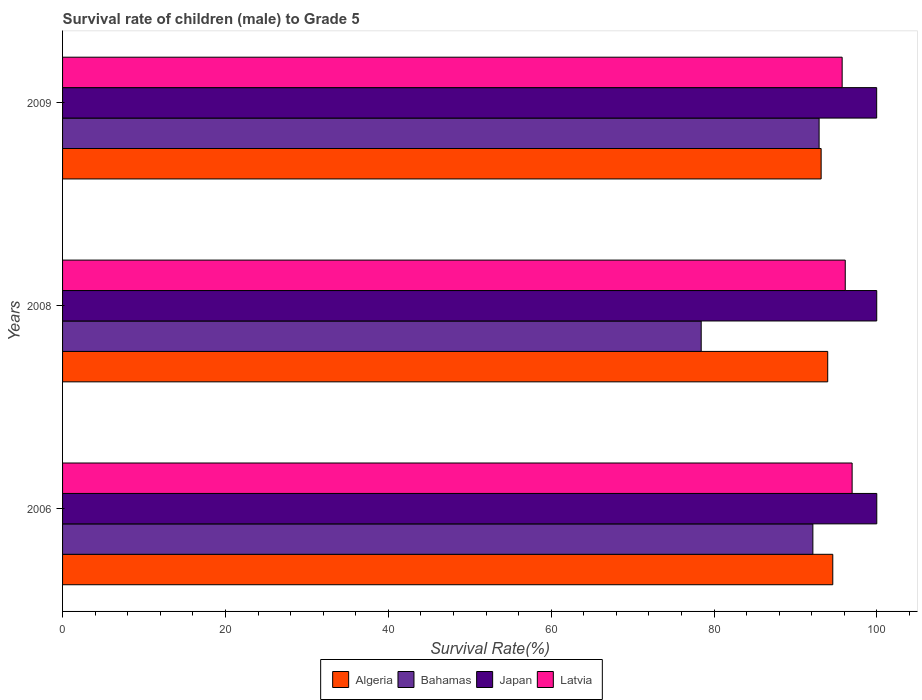How many different coloured bars are there?
Offer a terse response. 4. Are the number of bars on each tick of the Y-axis equal?
Your response must be concise. Yes. How many bars are there on the 3rd tick from the top?
Your answer should be compact. 4. How many bars are there on the 1st tick from the bottom?
Make the answer very short. 4. In how many cases, is the number of bars for a given year not equal to the number of legend labels?
Your response must be concise. 0. What is the survival rate of male children to grade 5 in Bahamas in 2009?
Ensure brevity in your answer.  92.91. Across all years, what is the maximum survival rate of male children to grade 5 in Latvia?
Provide a succinct answer. 96.96. Across all years, what is the minimum survival rate of male children to grade 5 in Japan?
Offer a terse response. 99.97. In which year was the survival rate of male children to grade 5 in Japan minimum?
Provide a succinct answer. 2009. What is the total survival rate of male children to grade 5 in Latvia in the graph?
Offer a very short reply. 288.81. What is the difference between the survival rate of male children to grade 5 in Bahamas in 2006 and that in 2009?
Make the answer very short. -0.77. What is the difference between the survival rate of male children to grade 5 in Bahamas in 2006 and the survival rate of male children to grade 5 in Latvia in 2009?
Your response must be concise. -3.6. What is the average survival rate of male children to grade 5 in Algeria per year?
Keep it short and to the point. 93.9. In the year 2008, what is the difference between the survival rate of male children to grade 5 in Algeria and survival rate of male children to grade 5 in Japan?
Provide a short and direct response. -6.02. In how many years, is the survival rate of male children to grade 5 in Latvia greater than 4 %?
Make the answer very short. 3. What is the ratio of the survival rate of male children to grade 5 in Bahamas in 2006 to that in 2008?
Make the answer very short. 1.17. Is the survival rate of male children to grade 5 in Latvia in 2006 less than that in 2008?
Keep it short and to the point. No. What is the difference between the highest and the second highest survival rate of male children to grade 5 in Japan?
Offer a very short reply. 0. What is the difference between the highest and the lowest survival rate of male children to grade 5 in Bahamas?
Give a very brief answer. 14.48. Is the sum of the survival rate of male children to grade 5 in Latvia in 2006 and 2008 greater than the maximum survival rate of male children to grade 5 in Japan across all years?
Offer a terse response. Yes. What does the 3rd bar from the top in 2008 represents?
Offer a very short reply. Bahamas. What does the 4th bar from the bottom in 2006 represents?
Offer a very short reply. Latvia. How many bars are there?
Make the answer very short. 12. Are all the bars in the graph horizontal?
Your answer should be very brief. Yes. How many years are there in the graph?
Offer a very short reply. 3. What is the difference between two consecutive major ticks on the X-axis?
Your answer should be compact. 20. How are the legend labels stacked?
Keep it short and to the point. Horizontal. What is the title of the graph?
Ensure brevity in your answer.  Survival rate of children (male) to Grade 5. What is the label or title of the X-axis?
Offer a very short reply. Survival Rate(%). What is the Survival Rate(%) of Algeria in 2006?
Ensure brevity in your answer.  94.58. What is the Survival Rate(%) in Bahamas in 2006?
Offer a terse response. 92.14. What is the Survival Rate(%) in Japan in 2006?
Your response must be concise. 99.99. What is the Survival Rate(%) in Latvia in 2006?
Provide a succinct answer. 96.96. What is the Survival Rate(%) of Algeria in 2008?
Your response must be concise. 93.96. What is the Survival Rate(%) in Bahamas in 2008?
Give a very brief answer. 78.43. What is the Survival Rate(%) in Japan in 2008?
Ensure brevity in your answer.  99.98. What is the Survival Rate(%) of Latvia in 2008?
Your answer should be compact. 96.12. What is the Survival Rate(%) in Algeria in 2009?
Provide a short and direct response. 93.16. What is the Survival Rate(%) of Bahamas in 2009?
Your response must be concise. 92.91. What is the Survival Rate(%) in Japan in 2009?
Provide a short and direct response. 99.97. What is the Survival Rate(%) of Latvia in 2009?
Provide a short and direct response. 95.74. Across all years, what is the maximum Survival Rate(%) of Algeria?
Provide a succinct answer. 94.58. Across all years, what is the maximum Survival Rate(%) of Bahamas?
Your answer should be very brief. 92.91. Across all years, what is the maximum Survival Rate(%) of Japan?
Ensure brevity in your answer.  99.99. Across all years, what is the maximum Survival Rate(%) in Latvia?
Keep it short and to the point. 96.96. Across all years, what is the minimum Survival Rate(%) of Algeria?
Provide a short and direct response. 93.16. Across all years, what is the minimum Survival Rate(%) of Bahamas?
Give a very brief answer. 78.43. Across all years, what is the minimum Survival Rate(%) of Japan?
Ensure brevity in your answer.  99.97. Across all years, what is the minimum Survival Rate(%) in Latvia?
Ensure brevity in your answer.  95.74. What is the total Survival Rate(%) in Algeria in the graph?
Provide a succinct answer. 281.7. What is the total Survival Rate(%) in Bahamas in the graph?
Offer a very short reply. 263.47. What is the total Survival Rate(%) of Japan in the graph?
Your answer should be very brief. 299.95. What is the total Survival Rate(%) of Latvia in the graph?
Offer a very short reply. 288.81. What is the difference between the Survival Rate(%) of Algeria in 2006 and that in 2008?
Provide a succinct answer. 0.62. What is the difference between the Survival Rate(%) in Bahamas in 2006 and that in 2008?
Make the answer very short. 13.71. What is the difference between the Survival Rate(%) in Japan in 2006 and that in 2008?
Your answer should be compact. 0. What is the difference between the Survival Rate(%) in Latvia in 2006 and that in 2008?
Your answer should be compact. 0.84. What is the difference between the Survival Rate(%) of Algeria in 2006 and that in 2009?
Offer a terse response. 1.43. What is the difference between the Survival Rate(%) in Bahamas in 2006 and that in 2009?
Your response must be concise. -0.77. What is the difference between the Survival Rate(%) in Japan in 2006 and that in 2009?
Offer a very short reply. 0.01. What is the difference between the Survival Rate(%) in Latvia in 2006 and that in 2009?
Your answer should be compact. 1.22. What is the difference between the Survival Rate(%) of Algeria in 2008 and that in 2009?
Provide a succinct answer. 0.81. What is the difference between the Survival Rate(%) in Bahamas in 2008 and that in 2009?
Your response must be concise. -14.48. What is the difference between the Survival Rate(%) of Japan in 2008 and that in 2009?
Provide a short and direct response. 0.01. What is the difference between the Survival Rate(%) of Latvia in 2008 and that in 2009?
Give a very brief answer. 0.38. What is the difference between the Survival Rate(%) of Algeria in 2006 and the Survival Rate(%) of Bahamas in 2008?
Offer a very short reply. 16.16. What is the difference between the Survival Rate(%) of Algeria in 2006 and the Survival Rate(%) of Japan in 2008?
Your answer should be compact. -5.4. What is the difference between the Survival Rate(%) in Algeria in 2006 and the Survival Rate(%) in Latvia in 2008?
Give a very brief answer. -1.53. What is the difference between the Survival Rate(%) of Bahamas in 2006 and the Survival Rate(%) of Japan in 2008?
Make the answer very short. -7.84. What is the difference between the Survival Rate(%) of Bahamas in 2006 and the Survival Rate(%) of Latvia in 2008?
Your answer should be very brief. -3.98. What is the difference between the Survival Rate(%) of Japan in 2006 and the Survival Rate(%) of Latvia in 2008?
Keep it short and to the point. 3.87. What is the difference between the Survival Rate(%) in Algeria in 2006 and the Survival Rate(%) in Bahamas in 2009?
Your response must be concise. 1.68. What is the difference between the Survival Rate(%) in Algeria in 2006 and the Survival Rate(%) in Japan in 2009?
Make the answer very short. -5.39. What is the difference between the Survival Rate(%) in Algeria in 2006 and the Survival Rate(%) in Latvia in 2009?
Your answer should be compact. -1.15. What is the difference between the Survival Rate(%) of Bahamas in 2006 and the Survival Rate(%) of Japan in 2009?
Offer a terse response. -7.83. What is the difference between the Survival Rate(%) of Bahamas in 2006 and the Survival Rate(%) of Latvia in 2009?
Make the answer very short. -3.6. What is the difference between the Survival Rate(%) of Japan in 2006 and the Survival Rate(%) of Latvia in 2009?
Make the answer very short. 4.25. What is the difference between the Survival Rate(%) of Algeria in 2008 and the Survival Rate(%) of Bahamas in 2009?
Your answer should be compact. 1.06. What is the difference between the Survival Rate(%) in Algeria in 2008 and the Survival Rate(%) in Japan in 2009?
Keep it short and to the point. -6.01. What is the difference between the Survival Rate(%) of Algeria in 2008 and the Survival Rate(%) of Latvia in 2009?
Keep it short and to the point. -1.77. What is the difference between the Survival Rate(%) of Bahamas in 2008 and the Survival Rate(%) of Japan in 2009?
Make the answer very short. -21.55. What is the difference between the Survival Rate(%) in Bahamas in 2008 and the Survival Rate(%) in Latvia in 2009?
Your response must be concise. -17.31. What is the difference between the Survival Rate(%) of Japan in 2008 and the Survival Rate(%) of Latvia in 2009?
Provide a short and direct response. 4.25. What is the average Survival Rate(%) of Algeria per year?
Provide a short and direct response. 93.9. What is the average Survival Rate(%) of Bahamas per year?
Your answer should be very brief. 87.82. What is the average Survival Rate(%) of Japan per year?
Provide a short and direct response. 99.98. What is the average Survival Rate(%) of Latvia per year?
Your answer should be very brief. 96.27. In the year 2006, what is the difference between the Survival Rate(%) in Algeria and Survival Rate(%) in Bahamas?
Provide a short and direct response. 2.44. In the year 2006, what is the difference between the Survival Rate(%) in Algeria and Survival Rate(%) in Japan?
Provide a succinct answer. -5.4. In the year 2006, what is the difference between the Survival Rate(%) in Algeria and Survival Rate(%) in Latvia?
Ensure brevity in your answer.  -2.38. In the year 2006, what is the difference between the Survival Rate(%) in Bahamas and Survival Rate(%) in Japan?
Give a very brief answer. -7.85. In the year 2006, what is the difference between the Survival Rate(%) in Bahamas and Survival Rate(%) in Latvia?
Your answer should be very brief. -4.82. In the year 2006, what is the difference between the Survival Rate(%) of Japan and Survival Rate(%) of Latvia?
Offer a very short reply. 3.03. In the year 2008, what is the difference between the Survival Rate(%) in Algeria and Survival Rate(%) in Bahamas?
Ensure brevity in your answer.  15.54. In the year 2008, what is the difference between the Survival Rate(%) in Algeria and Survival Rate(%) in Japan?
Your response must be concise. -6.02. In the year 2008, what is the difference between the Survival Rate(%) of Algeria and Survival Rate(%) of Latvia?
Your answer should be compact. -2.15. In the year 2008, what is the difference between the Survival Rate(%) of Bahamas and Survival Rate(%) of Japan?
Provide a short and direct response. -21.56. In the year 2008, what is the difference between the Survival Rate(%) in Bahamas and Survival Rate(%) in Latvia?
Provide a succinct answer. -17.69. In the year 2008, what is the difference between the Survival Rate(%) in Japan and Survival Rate(%) in Latvia?
Your response must be concise. 3.87. In the year 2009, what is the difference between the Survival Rate(%) in Algeria and Survival Rate(%) in Bahamas?
Ensure brevity in your answer.  0.25. In the year 2009, what is the difference between the Survival Rate(%) of Algeria and Survival Rate(%) of Japan?
Give a very brief answer. -6.82. In the year 2009, what is the difference between the Survival Rate(%) of Algeria and Survival Rate(%) of Latvia?
Make the answer very short. -2.58. In the year 2009, what is the difference between the Survival Rate(%) of Bahamas and Survival Rate(%) of Japan?
Make the answer very short. -7.07. In the year 2009, what is the difference between the Survival Rate(%) in Bahamas and Survival Rate(%) in Latvia?
Make the answer very short. -2.83. In the year 2009, what is the difference between the Survival Rate(%) of Japan and Survival Rate(%) of Latvia?
Provide a short and direct response. 4.24. What is the ratio of the Survival Rate(%) in Algeria in 2006 to that in 2008?
Provide a succinct answer. 1.01. What is the ratio of the Survival Rate(%) in Bahamas in 2006 to that in 2008?
Provide a short and direct response. 1.17. What is the ratio of the Survival Rate(%) in Japan in 2006 to that in 2008?
Make the answer very short. 1. What is the ratio of the Survival Rate(%) in Latvia in 2006 to that in 2008?
Your answer should be very brief. 1.01. What is the ratio of the Survival Rate(%) in Algeria in 2006 to that in 2009?
Provide a short and direct response. 1.02. What is the ratio of the Survival Rate(%) in Latvia in 2006 to that in 2009?
Your answer should be very brief. 1.01. What is the ratio of the Survival Rate(%) of Algeria in 2008 to that in 2009?
Offer a terse response. 1.01. What is the ratio of the Survival Rate(%) in Bahamas in 2008 to that in 2009?
Give a very brief answer. 0.84. What is the ratio of the Survival Rate(%) of Latvia in 2008 to that in 2009?
Provide a succinct answer. 1. What is the difference between the highest and the second highest Survival Rate(%) in Algeria?
Your answer should be compact. 0.62. What is the difference between the highest and the second highest Survival Rate(%) of Bahamas?
Offer a very short reply. 0.77. What is the difference between the highest and the second highest Survival Rate(%) in Japan?
Make the answer very short. 0. What is the difference between the highest and the second highest Survival Rate(%) of Latvia?
Keep it short and to the point. 0.84. What is the difference between the highest and the lowest Survival Rate(%) of Algeria?
Make the answer very short. 1.43. What is the difference between the highest and the lowest Survival Rate(%) of Bahamas?
Your answer should be compact. 14.48. What is the difference between the highest and the lowest Survival Rate(%) of Japan?
Give a very brief answer. 0.01. What is the difference between the highest and the lowest Survival Rate(%) in Latvia?
Give a very brief answer. 1.22. 